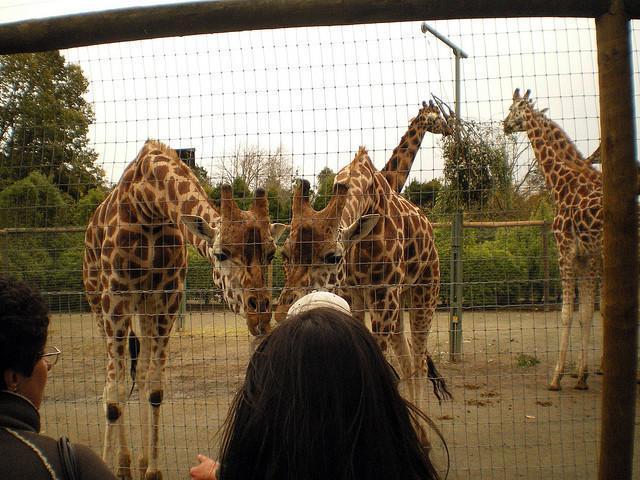How many giraffes are there?
Give a very brief answer. 4. How many people can be seen?
Give a very brief answer. 2. How many giraffes are in the picture?
Give a very brief answer. 4. How many of the stuffed bears have a heart on its chest?
Give a very brief answer. 0. 